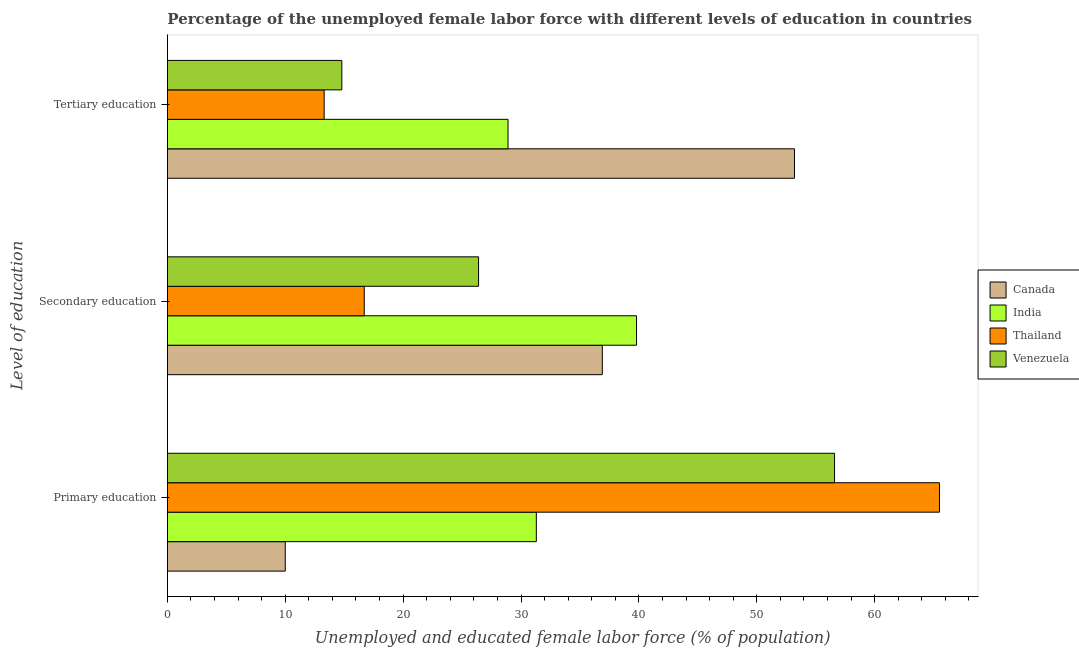How many different coloured bars are there?
Provide a short and direct response. 4. Are the number of bars on each tick of the Y-axis equal?
Give a very brief answer. Yes. Across all countries, what is the maximum percentage of female labor force who received secondary education?
Keep it short and to the point. 39.8. Across all countries, what is the minimum percentage of female labor force who received secondary education?
Provide a short and direct response. 16.7. In which country was the percentage of female labor force who received tertiary education minimum?
Your answer should be very brief. Thailand. What is the total percentage of female labor force who received secondary education in the graph?
Keep it short and to the point. 119.8. What is the difference between the percentage of female labor force who received primary education in Venezuela and that in India?
Offer a terse response. 25.3. What is the difference between the percentage of female labor force who received tertiary education in Canada and the percentage of female labor force who received secondary education in India?
Give a very brief answer. 13.4. What is the average percentage of female labor force who received tertiary education per country?
Provide a succinct answer. 27.55. What is the difference between the percentage of female labor force who received tertiary education and percentage of female labor force who received secondary education in Thailand?
Offer a very short reply. -3.4. What is the ratio of the percentage of female labor force who received tertiary education in Canada to that in Venezuela?
Keep it short and to the point. 3.59. Is the percentage of female labor force who received tertiary education in Thailand less than that in Canada?
Keep it short and to the point. Yes. Is the difference between the percentage of female labor force who received secondary education in Thailand and Canada greater than the difference between the percentage of female labor force who received tertiary education in Thailand and Canada?
Keep it short and to the point. Yes. What is the difference between the highest and the second highest percentage of female labor force who received tertiary education?
Keep it short and to the point. 24.3. What is the difference between the highest and the lowest percentage of female labor force who received primary education?
Your answer should be very brief. 55.5. In how many countries, is the percentage of female labor force who received tertiary education greater than the average percentage of female labor force who received tertiary education taken over all countries?
Give a very brief answer. 2. What does the 4th bar from the top in Tertiary education represents?
Offer a terse response. Canada. Are all the bars in the graph horizontal?
Your answer should be compact. Yes. How many countries are there in the graph?
Provide a short and direct response. 4. What is the difference between two consecutive major ticks on the X-axis?
Offer a terse response. 10. Are the values on the major ticks of X-axis written in scientific E-notation?
Ensure brevity in your answer.  No. Does the graph contain any zero values?
Provide a succinct answer. No. Where does the legend appear in the graph?
Make the answer very short. Center right. How many legend labels are there?
Offer a very short reply. 4. How are the legend labels stacked?
Your answer should be compact. Vertical. What is the title of the graph?
Offer a terse response. Percentage of the unemployed female labor force with different levels of education in countries. Does "Guinea" appear as one of the legend labels in the graph?
Offer a terse response. No. What is the label or title of the X-axis?
Your answer should be compact. Unemployed and educated female labor force (% of population). What is the label or title of the Y-axis?
Offer a terse response. Level of education. What is the Unemployed and educated female labor force (% of population) in Canada in Primary education?
Ensure brevity in your answer.  10. What is the Unemployed and educated female labor force (% of population) of India in Primary education?
Provide a short and direct response. 31.3. What is the Unemployed and educated female labor force (% of population) in Thailand in Primary education?
Provide a succinct answer. 65.5. What is the Unemployed and educated female labor force (% of population) of Venezuela in Primary education?
Keep it short and to the point. 56.6. What is the Unemployed and educated female labor force (% of population) of Canada in Secondary education?
Provide a succinct answer. 36.9. What is the Unemployed and educated female labor force (% of population) of India in Secondary education?
Offer a terse response. 39.8. What is the Unemployed and educated female labor force (% of population) of Thailand in Secondary education?
Offer a terse response. 16.7. What is the Unemployed and educated female labor force (% of population) in Venezuela in Secondary education?
Your answer should be very brief. 26.4. What is the Unemployed and educated female labor force (% of population) of Canada in Tertiary education?
Keep it short and to the point. 53.2. What is the Unemployed and educated female labor force (% of population) of India in Tertiary education?
Your answer should be very brief. 28.9. What is the Unemployed and educated female labor force (% of population) in Thailand in Tertiary education?
Your answer should be very brief. 13.3. What is the Unemployed and educated female labor force (% of population) of Venezuela in Tertiary education?
Make the answer very short. 14.8. Across all Level of education, what is the maximum Unemployed and educated female labor force (% of population) in Canada?
Keep it short and to the point. 53.2. Across all Level of education, what is the maximum Unemployed and educated female labor force (% of population) of India?
Your response must be concise. 39.8. Across all Level of education, what is the maximum Unemployed and educated female labor force (% of population) in Thailand?
Offer a very short reply. 65.5. Across all Level of education, what is the maximum Unemployed and educated female labor force (% of population) in Venezuela?
Your answer should be very brief. 56.6. Across all Level of education, what is the minimum Unemployed and educated female labor force (% of population) in Canada?
Provide a succinct answer. 10. Across all Level of education, what is the minimum Unemployed and educated female labor force (% of population) of India?
Your answer should be compact. 28.9. Across all Level of education, what is the minimum Unemployed and educated female labor force (% of population) of Thailand?
Your response must be concise. 13.3. Across all Level of education, what is the minimum Unemployed and educated female labor force (% of population) in Venezuela?
Make the answer very short. 14.8. What is the total Unemployed and educated female labor force (% of population) in Canada in the graph?
Offer a terse response. 100.1. What is the total Unemployed and educated female labor force (% of population) of Thailand in the graph?
Keep it short and to the point. 95.5. What is the total Unemployed and educated female labor force (% of population) in Venezuela in the graph?
Offer a very short reply. 97.8. What is the difference between the Unemployed and educated female labor force (% of population) of Canada in Primary education and that in Secondary education?
Make the answer very short. -26.9. What is the difference between the Unemployed and educated female labor force (% of population) in Thailand in Primary education and that in Secondary education?
Offer a very short reply. 48.8. What is the difference between the Unemployed and educated female labor force (% of population) of Venezuela in Primary education and that in Secondary education?
Your answer should be compact. 30.2. What is the difference between the Unemployed and educated female labor force (% of population) in Canada in Primary education and that in Tertiary education?
Ensure brevity in your answer.  -43.2. What is the difference between the Unemployed and educated female labor force (% of population) in India in Primary education and that in Tertiary education?
Provide a succinct answer. 2.4. What is the difference between the Unemployed and educated female labor force (% of population) in Thailand in Primary education and that in Tertiary education?
Give a very brief answer. 52.2. What is the difference between the Unemployed and educated female labor force (% of population) in Venezuela in Primary education and that in Tertiary education?
Provide a short and direct response. 41.8. What is the difference between the Unemployed and educated female labor force (% of population) in Canada in Secondary education and that in Tertiary education?
Keep it short and to the point. -16.3. What is the difference between the Unemployed and educated female labor force (% of population) in Venezuela in Secondary education and that in Tertiary education?
Keep it short and to the point. 11.6. What is the difference between the Unemployed and educated female labor force (% of population) in Canada in Primary education and the Unemployed and educated female labor force (% of population) in India in Secondary education?
Offer a terse response. -29.8. What is the difference between the Unemployed and educated female labor force (% of population) in Canada in Primary education and the Unemployed and educated female labor force (% of population) in Thailand in Secondary education?
Your answer should be compact. -6.7. What is the difference between the Unemployed and educated female labor force (% of population) of Canada in Primary education and the Unemployed and educated female labor force (% of population) of Venezuela in Secondary education?
Your answer should be compact. -16.4. What is the difference between the Unemployed and educated female labor force (% of population) of India in Primary education and the Unemployed and educated female labor force (% of population) of Thailand in Secondary education?
Provide a succinct answer. 14.6. What is the difference between the Unemployed and educated female labor force (% of population) of Thailand in Primary education and the Unemployed and educated female labor force (% of population) of Venezuela in Secondary education?
Provide a succinct answer. 39.1. What is the difference between the Unemployed and educated female labor force (% of population) of Canada in Primary education and the Unemployed and educated female labor force (% of population) of India in Tertiary education?
Ensure brevity in your answer.  -18.9. What is the difference between the Unemployed and educated female labor force (% of population) in Canada in Primary education and the Unemployed and educated female labor force (% of population) in Venezuela in Tertiary education?
Ensure brevity in your answer.  -4.8. What is the difference between the Unemployed and educated female labor force (% of population) of Thailand in Primary education and the Unemployed and educated female labor force (% of population) of Venezuela in Tertiary education?
Your answer should be compact. 50.7. What is the difference between the Unemployed and educated female labor force (% of population) in Canada in Secondary education and the Unemployed and educated female labor force (% of population) in India in Tertiary education?
Provide a succinct answer. 8. What is the difference between the Unemployed and educated female labor force (% of population) in Canada in Secondary education and the Unemployed and educated female labor force (% of population) in Thailand in Tertiary education?
Keep it short and to the point. 23.6. What is the difference between the Unemployed and educated female labor force (% of population) in Canada in Secondary education and the Unemployed and educated female labor force (% of population) in Venezuela in Tertiary education?
Your answer should be very brief. 22.1. What is the difference between the Unemployed and educated female labor force (% of population) of India in Secondary education and the Unemployed and educated female labor force (% of population) of Thailand in Tertiary education?
Provide a succinct answer. 26.5. What is the difference between the Unemployed and educated female labor force (% of population) of Thailand in Secondary education and the Unemployed and educated female labor force (% of population) of Venezuela in Tertiary education?
Your response must be concise. 1.9. What is the average Unemployed and educated female labor force (% of population) in Canada per Level of education?
Your answer should be compact. 33.37. What is the average Unemployed and educated female labor force (% of population) of India per Level of education?
Provide a succinct answer. 33.33. What is the average Unemployed and educated female labor force (% of population) in Thailand per Level of education?
Your response must be concise. 31.83. What is the average Unemployed and educated female labor force (% of population) in Venezuela per Level of education?
Ensure brevity in your answer.  32.6. What is the difference between the Unemployed and educated female labor force (% of population) of Canada and Unemployed and educated female labor force (% of population) of India in Primary education?
Provide a succinct answer. -21.3. What is the difference between the Unemployed and educated female labor force (% of population) of Canada and Unemployed and educated female labor force (% of population) of Thailand in Primary education?
Give a very brief answer. -55.5. What is the difference between the Unemployed and educated female labor force (% of population) of Canada and Unemployed and educated female labor force (% of population) of Venezuela in Primary education?
Give a very brief answer. -46.6. What is the difference between the Unemployed and educated female labor force (% of population) in India and Unemployed and educated female labor force (% of population) in Thailand in Primary education?
Your answer should be very brief. -34.2. What is the difference between the Unemployed and educated female labor force (% of population) in India and Unemployed and educated female labor force (% of population) in Venezuela in Primary education?
Your answer should be very brief. -25.3. What is the difference between the Unemployed and educated female labor force (% of population) of Thailand and Unemployed and educated female labor force (% of population) of Venezuela in Primary education?
Provide a short and direct response. 8.9. What is the difference between the Unemployed and educated female labor force (% of population) of Canada and Unemployed and educated female labor force (% of population) of Thailand in Secondary education?
Offer a terse response. 20.2. What is the difference between the Unemployed and educated female labor force (% of population) of India and Unemployed and educated female labor force (% of population) of Thailand in Secondary education?
Offer a terse response. 23.1. What is the difference between the Unemployed and educated female labor force (% of population) in Canada and Unemployed and educated female labor force (% of population) in India in Tertiary education?
Keep it short and to the point. 24.3. What is the difference between the Unemployed and educated female labor force (% of population) in Canada and Unemployed and educated female labor force (% of population) in Thailand in Tertiary education?
Give a very brief answer. 39.9. What is the difference between the Unemployed and educated female labor force (% of population) of Canada and Unemployed and educated female labor force (% of population) of Venezuela in Tertiary education?
Ensure brevity in your answer.  38.4. What is the difference between the Unemployed and educated female labor force (% of population) of India and Unemployed and educated female labor force (% of population) of Thailand in Tertiary education?
Your response must be concise. 15.6. What is the ratio of the Unemployed and educated female labor force (% of population) of Canada in Primary education to that in Secondary education?
Your answer should be compact. 0.27. What is the ratio of the Unemployed and educated female labor force (% of population) of India in Primary education to that in Secondary education?
Offer a terse response. 0.79. What is the ratio of the Unemployed and educated female labor force (% of population) of Thailand in Primary education to that in Secondary education?
Your response must be concise. 3.92. What is the ratio of the Unemployed and educated female labor force (% of population) in Venezuela in Primary education to that in Secondary education?
Offer a terse response. 2.14. What is the ratio of the Unemployed and educated female labor force (% of population) of Canada in Primary education to that in Tertiary education?
Make the answer very short. 0.19. What is the ratio of the Unemployed and educated female labor force (% of population) in India in Primary education to that in Tertiary education?
Provide a succinct answer. 1.08. What is the ratio of the Unemployed and educated female labor force (% of population) in Thailand in Primary education to that in Tertiary education?
Your answer should be compact. 4.92. What is the ratio of the Unemployed and educated female labor force (% of population) of Venezuela in Primary education to that in Tertiary education?
Provide a succinct answer. 3.82. What is the ratio of the Unemployed and educated female labor force (% of population) of Canada in Secondary education to that in Tertiary education?
Your answer should be compact. 0.69. What is the ratio of the Unemployed and educated female labor force (% of population) in India in Secondary education to that in Tertiary education?
Ensure brevity in your answer.  1.38. What is the ratio of the Unemployed and educated female labor force (% of population) in Thailand in Secondary education to that in Tertiary education?
Offer a terse response. 1.26. What is the ratio of the Unemployed and educated female labor force (% of population) in Venezuela in Secondary education to that in Tertiary education?
Keep it short and to the point. 1.78. What is the difference between the highest and the second highest Unemployed and educated female labor force (% of population) of India?
Your answer should be compact. 8.5. What is the difference between the highest and the second highest Unemployed and educated female labor force (% of population) in Thailand?
Provide a succinct answer. 48.8. What is the difference between the highest and the second highest Unemployed and educated female labor force (% of population) in Venezuela?
Offer a very short reply. 30.2. What is the difference between the highest and the lowest Unemployed and educated female labor force (% of population) in Canada?
Provide a succinct answer. 43.2. What is the difference between the highest and the lowest Unemployed and educated female labor force (% of population) in Thailand?
Make the answer very short. 52.2. What is the difference between the highest and the lowest Unemployed and educated female labor force (% of population) of Venezuela?
Offer a very short reply. 41.8. 